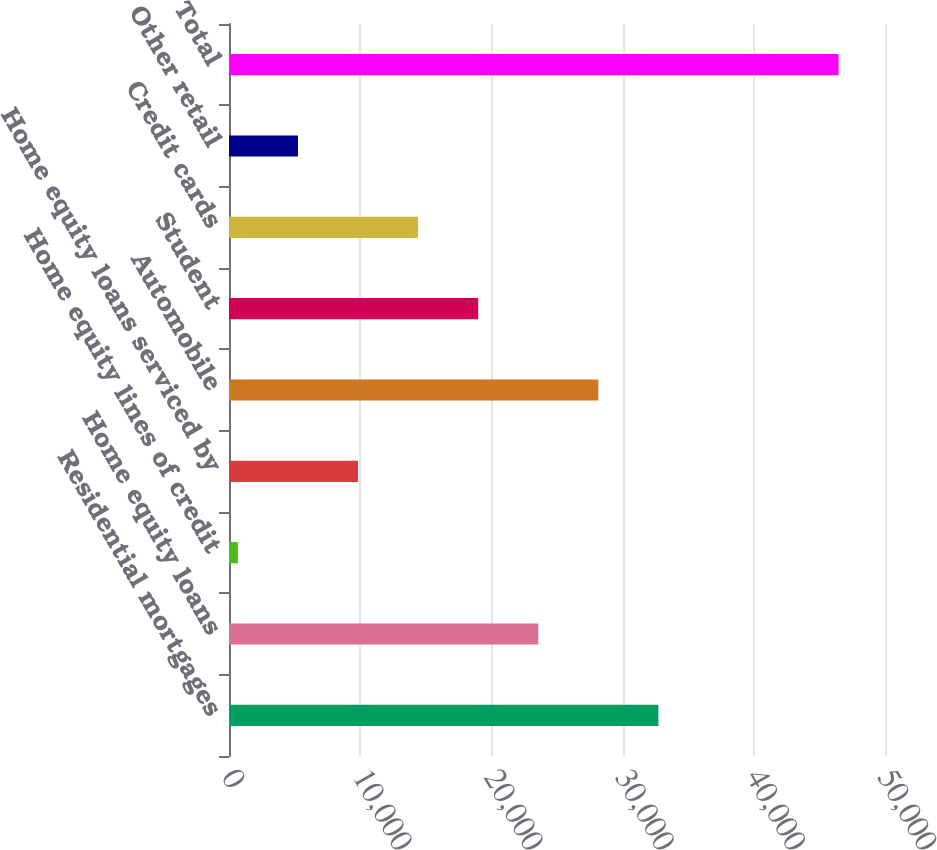Convert chart to OTSL. <chart><loc_0><loc_0><loc_500><loc_500><bar_chart><fcel>Residential mortgages<fcel>Home equity loans<fcel>Home equity lines of credit<fcel>Home equity loans serviced by<fcel>Automobile<fcel>Student<fcel>Credit cards<fcel>Other retail<fcel>Total<nl><fcel>32728.5<fcel>23571.5<fcel>679<fcel>9836<fcel>28150<fcel>18993<fcel>14414.5<fcel>5257.5<fcel>46464<nl></chart> 